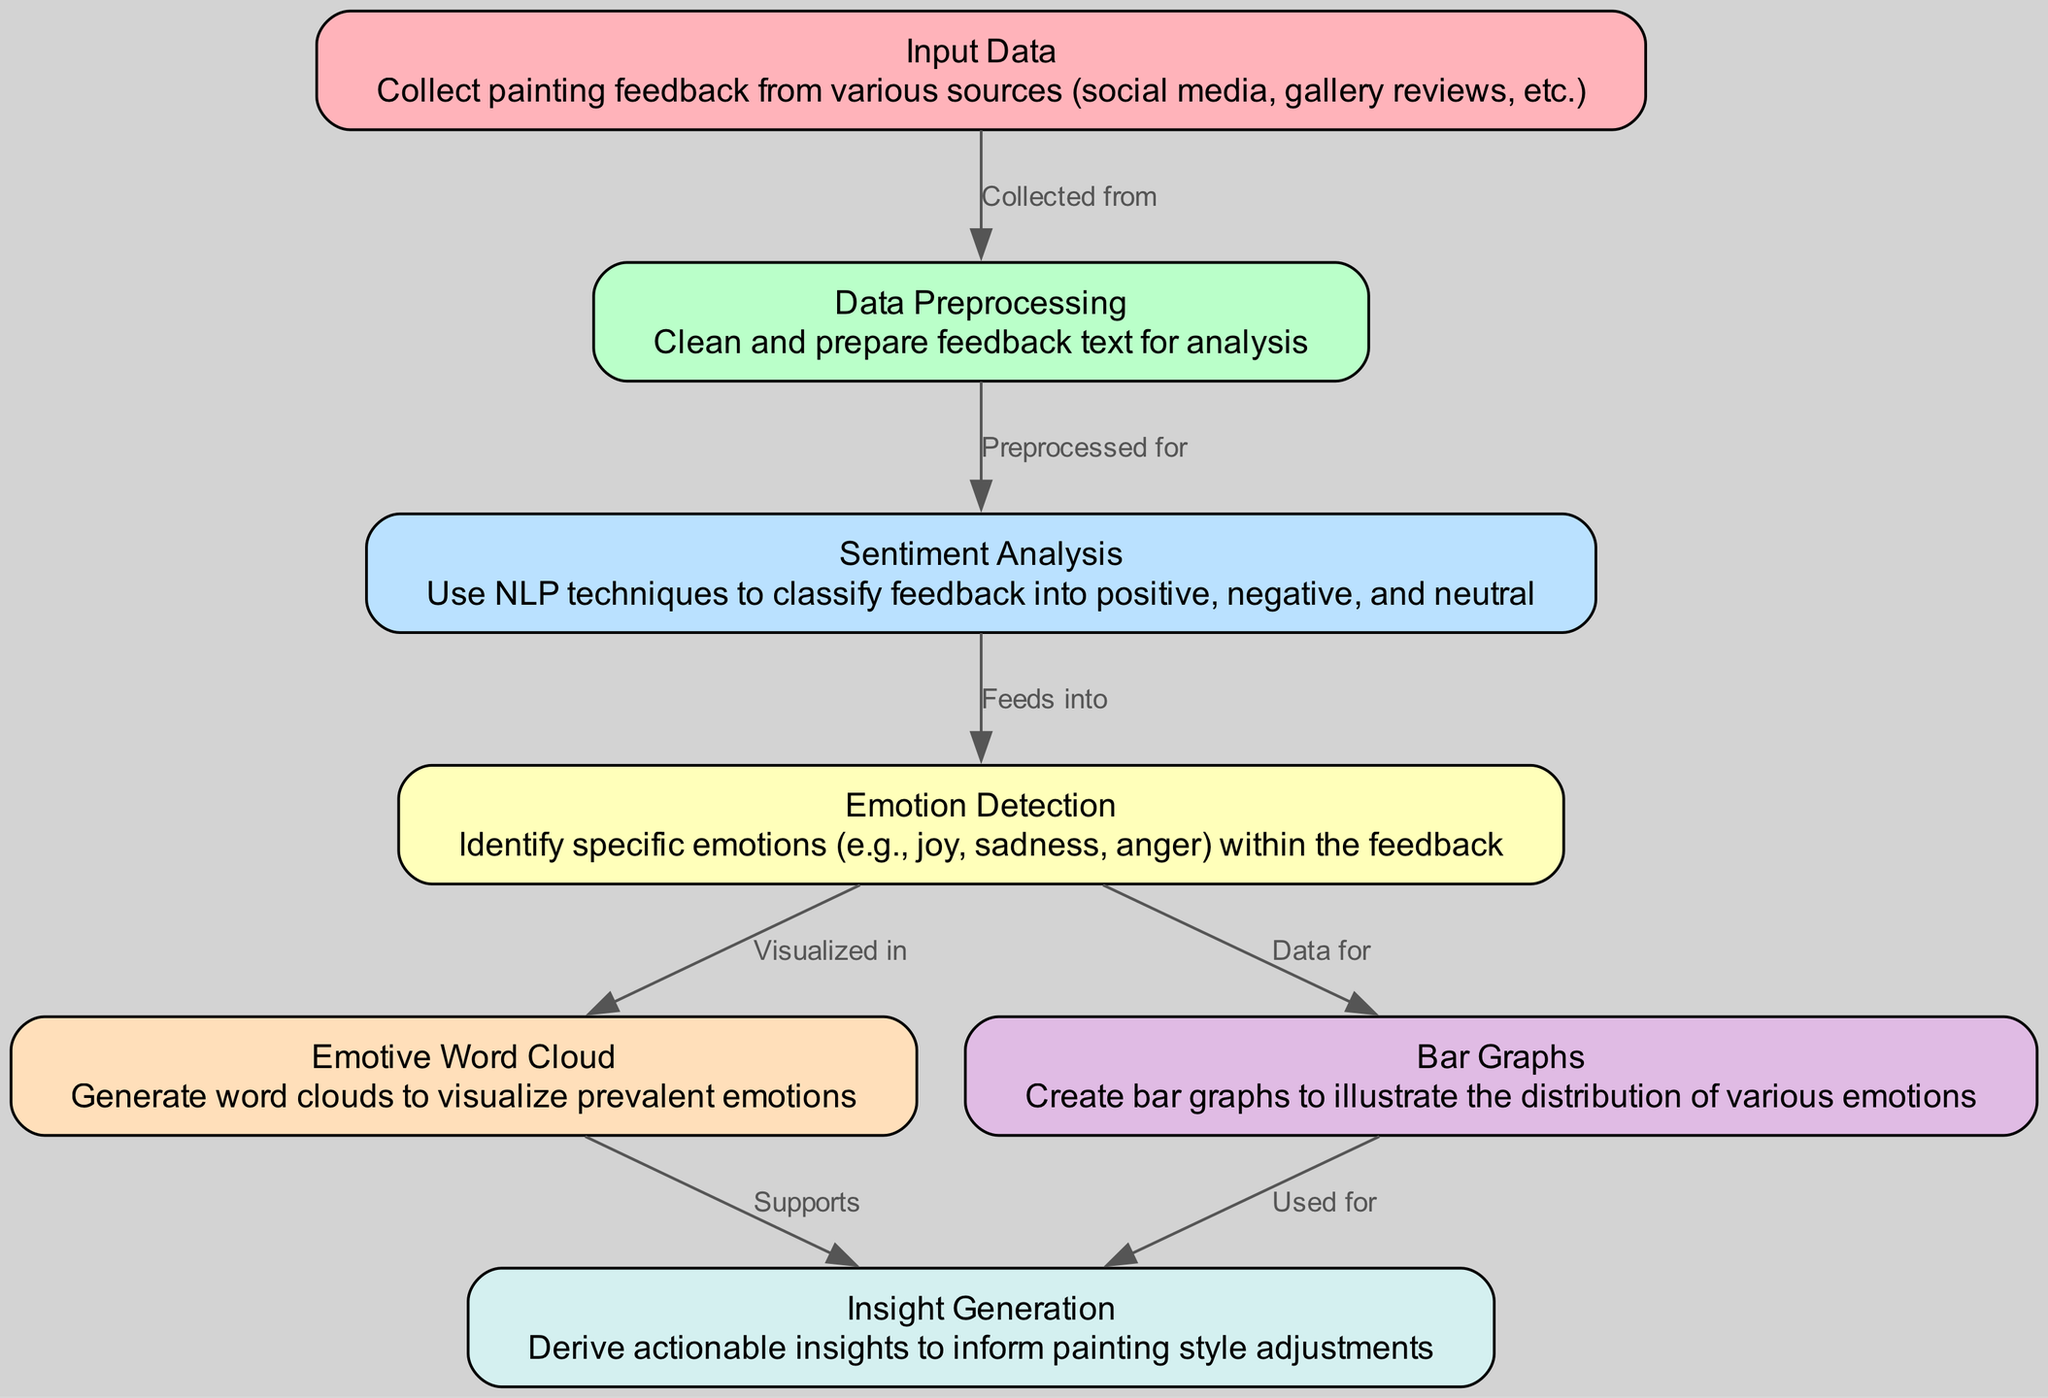What is the first step in the diagram? The first step in the diagram is represented by the node "Input Data." It indicates that the process begins with collecting painting feedback from various sources.
Answer: Input Data How many nodes are present in the diagram? The diagram contains seven distinct nodes, each representing a unique step in the audience sentiment analysis process.
Answer: 7 What type of analysis follows data preprocessing? After data preprocessing is completed, the next step is "Sentiment Analysis," where feedback is classified into positive, negative, and neutral categories.
Answer: Sentiment Analysis Which two visualizations are produced after emotion detection? After "Emotion Detection," the process leads to "Emotive Word Cloud" and "Bar Graphs," which visualize the prevalent emotions within the feedback in two distinct formats.
Answer: Emotive Word Cloud and Bar Graphs What supports insight generation in the diagram? The insights generation process is supported by the "Emotive Word Cloud," which visually represents the emotions, aiding in the understanding of audience sentiment.
Answer: Emotive Word Cloud How is emotion detection linked to sentiment analysis? "Emotion Detection" feeds information from "Sentiment Analysis," indicating that it's an extension of the sentiments classified in the previous step, focusing on specific emotions within the feedback.
Answer: Feeds into What is illustrated by the bar graphs in this diagram? The "Bar Graphs" visually illustrate the distribution of various emotions identified from the feedback, providing a comparative look at audience reactions.
Answer: Distribution of various emotions Which node describes the cleaning and preparation process? The node labeled "Data Preprocessing" is responsible for cleaning and preparing the feedback text for the subsequent analyses, ensuring that the data used is suitable for sentiment analysis.
Answer: Data Preprocessing What is the outcome of the whole process depicted in the diagram? The outcome of the steps represented in the diagram culminates in "Insight Generation," where actionable insights are derived to inform potential adjustments in painting style based on audience sentiment.
Answer: Insight Generation 